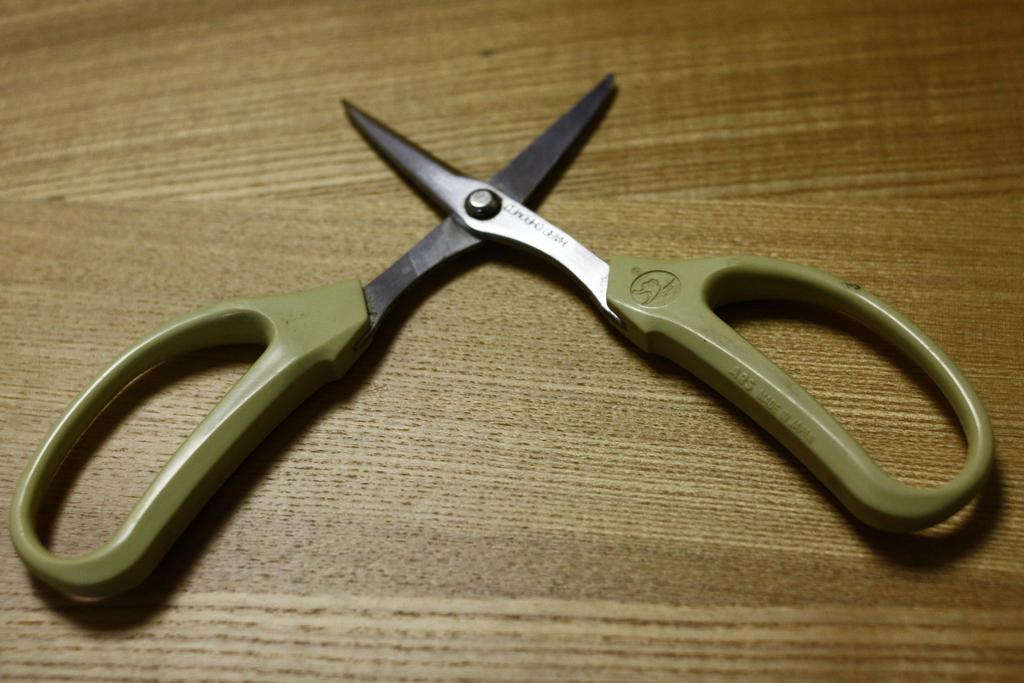What type of tool is on the wooden surface in the image? There are scissors on a wooden surface in the image. What material is the surface made of? The surface is made of wood. What is the plot of the story involving the thumb in the image? There is no story or thumb present in the image; it only features scissors on a wooden surface. 